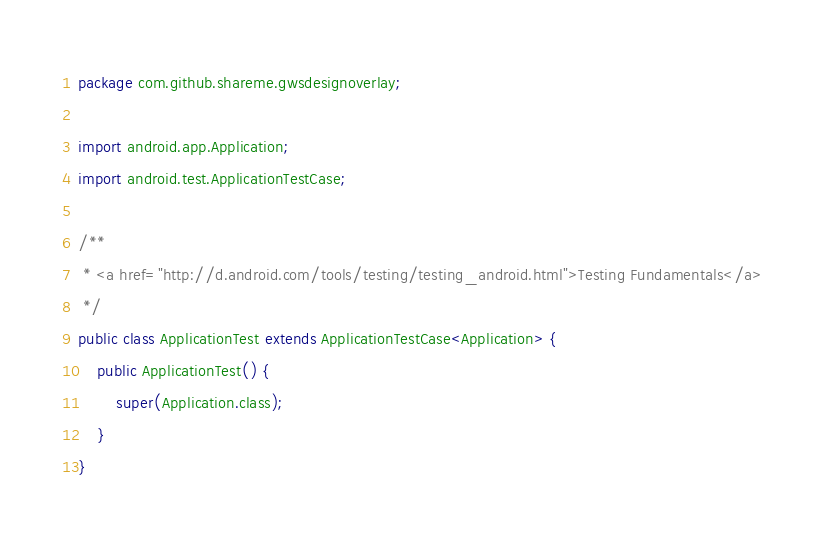<code> <loc_0><loc_0><loc_500><loc_500><_Java_>package com.github.shareme.gwsdesignoverlay;

import android.app.Application;
import android.test.ApplicationTestCase;

/**
 * <a href="http://d.android.com/tools/testing/testing_android.html">Testing Fundamentals</a>
 */
public class ApplicationTest extends ApplicationTestCase<Application> {
    public ApplicationTest() {
        super(Application.class);
    }
}</code> 